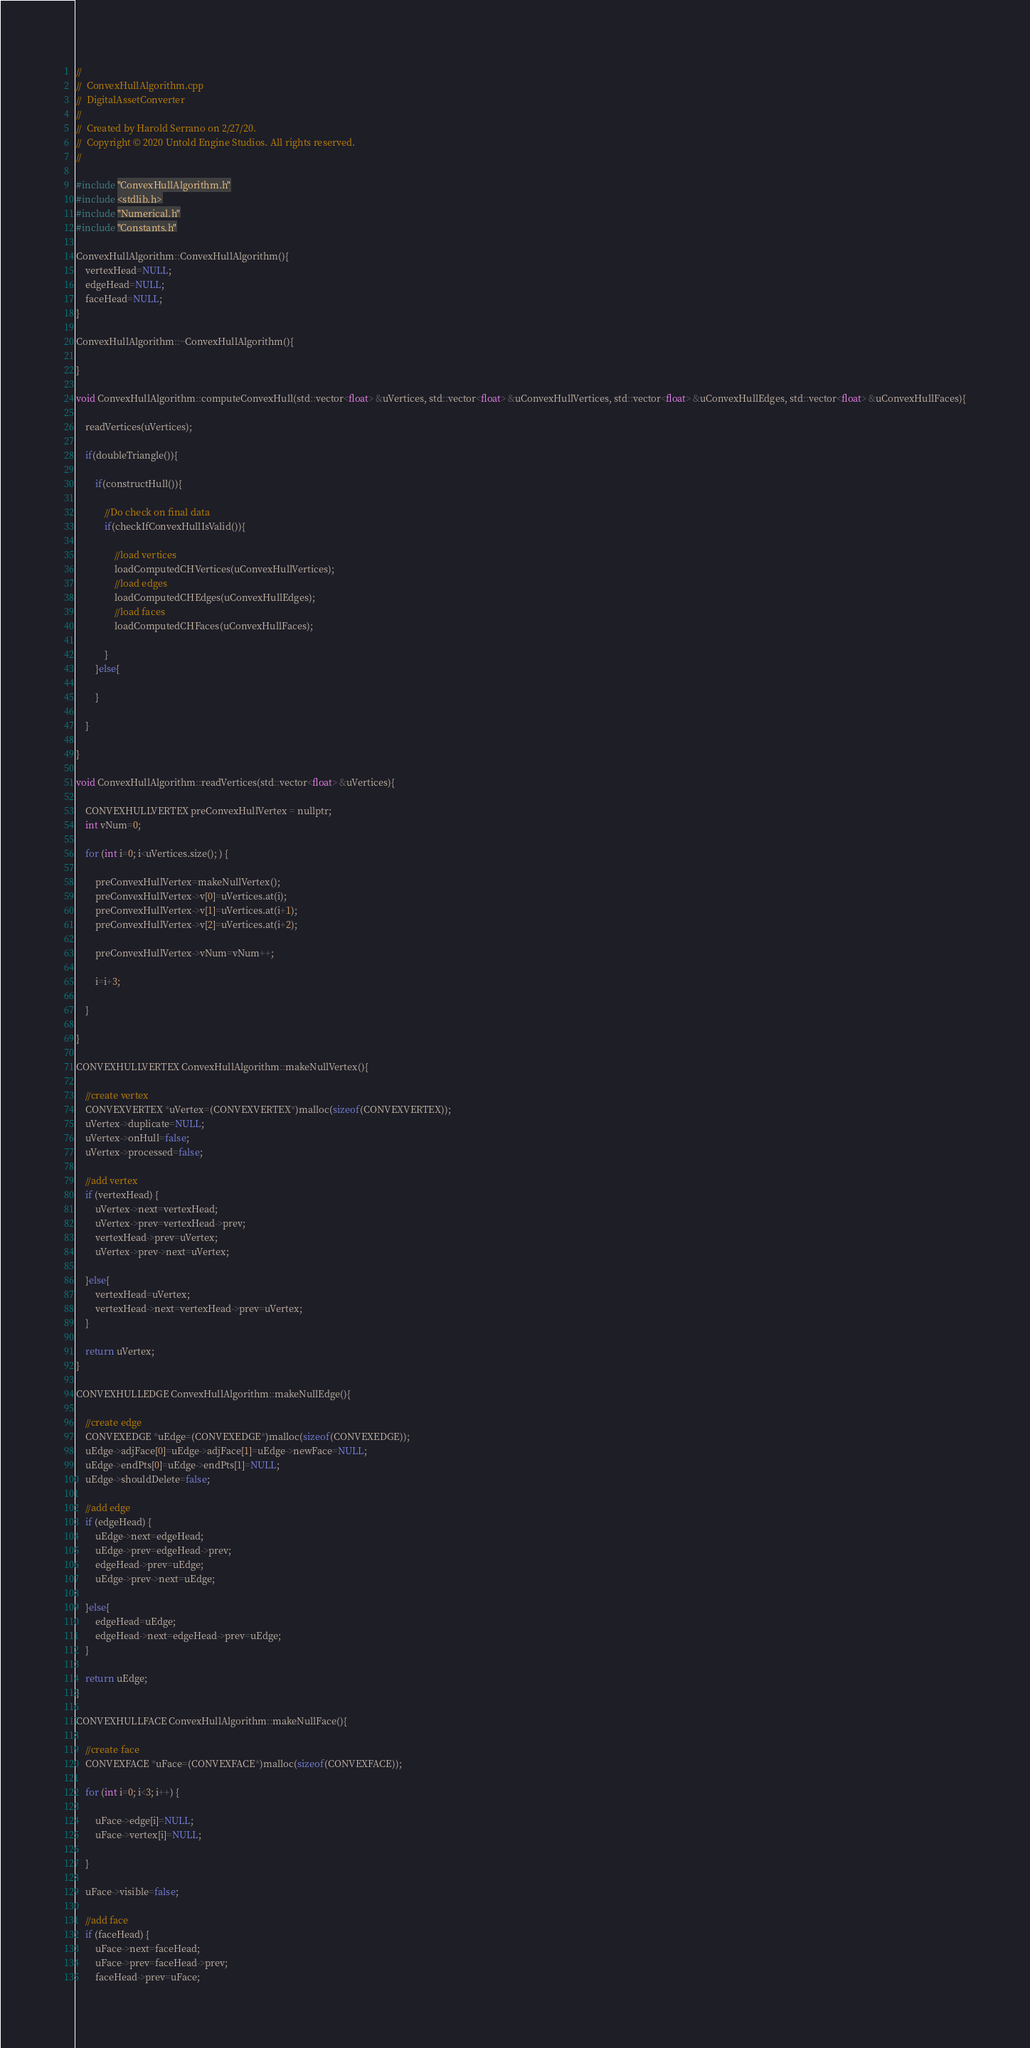Convert code to text. <code><loc_0><loc_0><loc_500><loc_500><_ObjectiveC_>//
//  ConvexHullAlgorithm.cpp
//  DigitalAssetConverter
//
//  Created by Harold Serrano on 2/27/20.
//  Copyright © 2020 Untold Engine Studios. All rights reserved.
//

#include "ConvexHullAlgorithm.h"
#include <stdlib.h>
#include "Numerical.h"
#include "Constants.h"

ConvexHullAlgorithm::ConvexHullAlgorithm(){
    vertexHead=NULL;
    edgeHead=NULL;
    faceHead=NULL;
}

ConvexHullAlgorithm::~ConvexHullAlgorithm(){
    
}

void ConvexHullAlgorithm::computeConvexHull(std::vector<float> &uVertices, std::vector<float> &uConvexHullVertices, std::vector<float> &uConvexHullEdges, std::vector<float> &uConvexHullFaces){
    
    readVertices(uVertices);
    
    if(doubleTriangle()){
        
        if(constructHull()){
            
            //Do check on final data
            if(checkIfConvexHullIsValid()){
                
                //load vertices
                loadComputedCHVertices(uConvexHullVertices);
                //load edges
                loadComputedCHEdges(uConvexHullEdges);
                //load faces
                loadComputedCHFaces(uConvexHullFaces);
                
            }
        }else{
            
        }
        
    }
    
}

void ConvexHullAlgorithm::readVertices(std::vector<float> &uVertices){
    
    CONVEXHULLVERTEX preConvexHullVertex = nullptr;
    int vNum=0;
    
    for (int i=0; i<uVertices.size(); ) {
        
        preConvexHullVertex=makeNullVertex();
        preConvexHullVertex->v[0]=uVertices.at(i);
        preConvexHullVertex->v[1]=uVertices.at(i+1);
        preConvexHullVertex->v[2]=uVertices.at(i+2);
        
        preConvexHullVertex->vNum=vNum++;
        
        i=i+3;
        
    }
    
}

CONVEXHULLVERTEX ConvexHullAlgorithm::makeNullVertex(){
    
    //create vertex
    CONVEXVERTEX *uVertex=(CONVEXVERTEX*)malloc(sizeof(CONVEXVERTEX));
    uVertex->duplicate=NULL;
    uVertex->onHull=false;
    uVertex->processed=false;
    
    //add vertex
    if (vertexHead) {
        uVertex->next=vertexHead;
        uVertex->prev=vertexHead->prev;
        vertexHead->prev=uVertex;
        uVertex->prev->next=uVertex;
        
    }else{
        vertexHead=uVertex;
        vertexHead->next=vertexHead->prev=uVertex;
    }
    
    return uVertex;
}

CONVEXHULLEDGE ConvexHullAlgorithm::makeNullEdge(){
    
    //create edge
    CONVEXEDGE *uEdge=(CONVEXEDGE*)malloc(sizeof(CONVEXEDGE));
    uEdge->adjFace[0]=uEdge->adjFace[1]=uEdge->newFace=NULL;
    uEdge->endPts[0]=uEdge->endPts[1]=NULL;
    uEdge->shouldDelete=false;
    
    //add edge
    if (edgeHead) {
        uEdge->next=edgeHead;
        uEdge->prev=edgeHead->prev;
        edgeHead->prev=uEdge;
        uEdge->prev->next=uEdge;
        
    }else{
        edgeHead=uEdge;
        edgeHead->next=edgeHead->prev=uEdge;
    }
    
    return uEdge;
}

CONVEXHULLFACE ConvexHullAlgorithm::makeNullFace(){
    
    //create face
    CONVEXFACE *uFace=(CONVEXFACE*)malloc(sizeof(CONVEXFACE));
    
    for (int i=0; i<3; i++) {
        
        uFace->edge[i]=NULL;
        uFace->vertex[i]=NULL;
        
    }
    
    uFace->visible=false;
    
    //add face
    if (faceHead) {
        uFace->next=faceHead;
        uFace->prev=faceHead->prev;
        faceHead->prev=uFace;</code> 